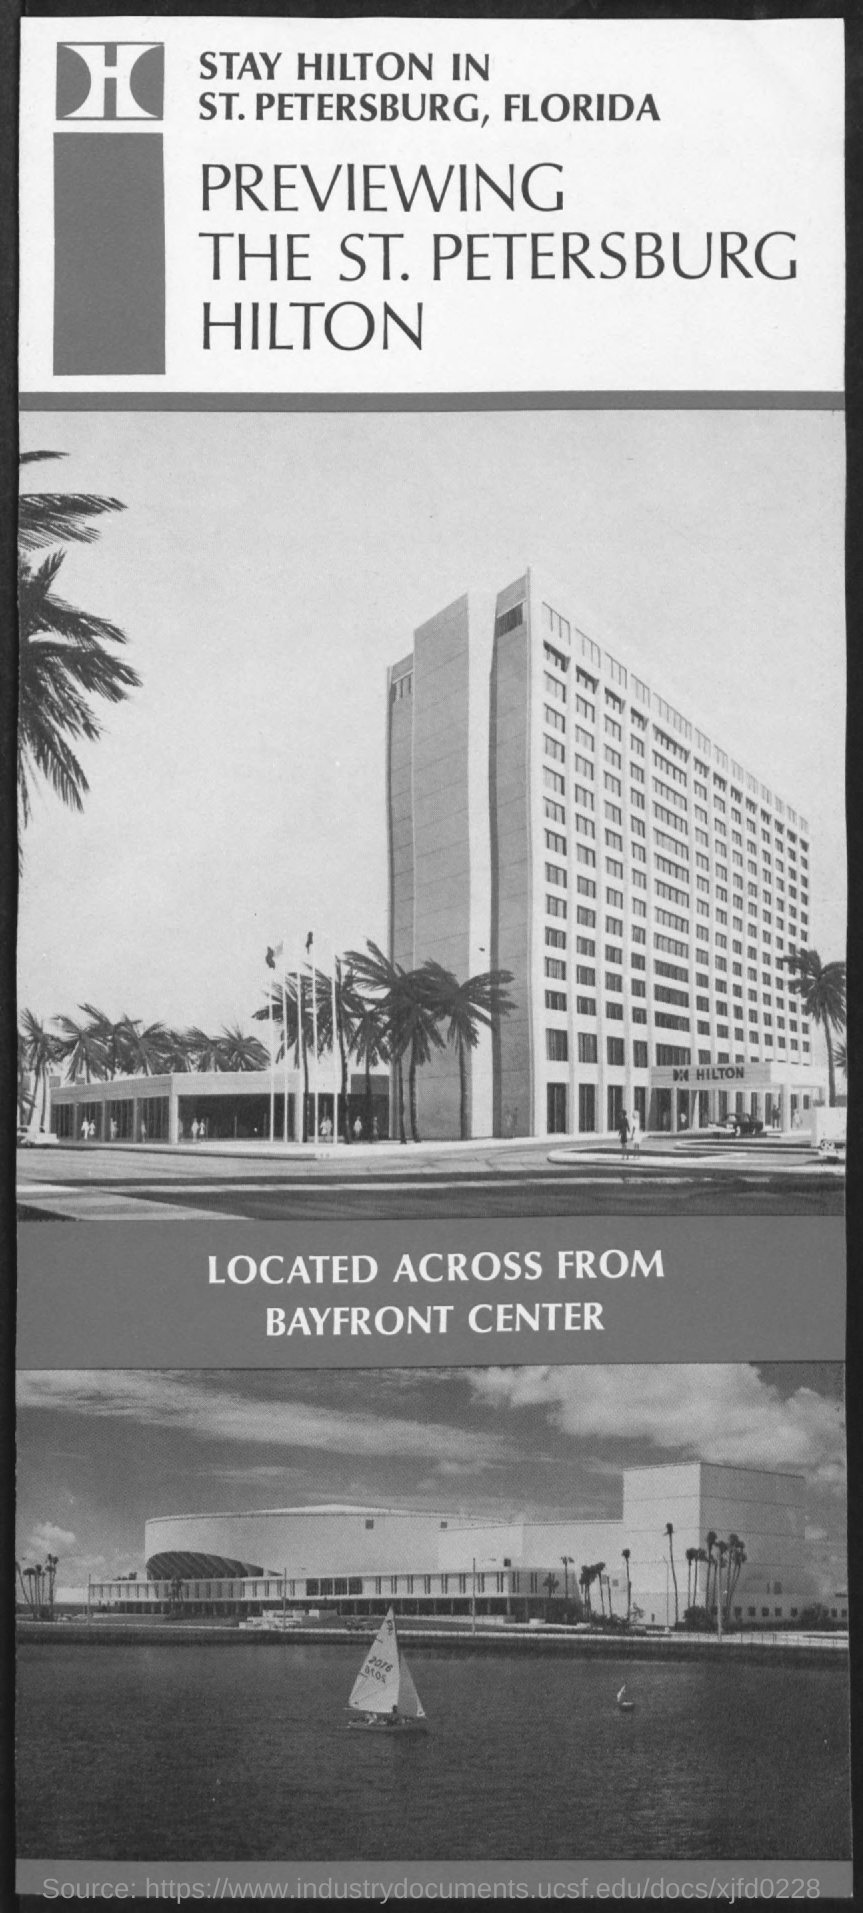Outline some significant characteristics in this image. The third title in the document is "Located across from Bayfront Center. 